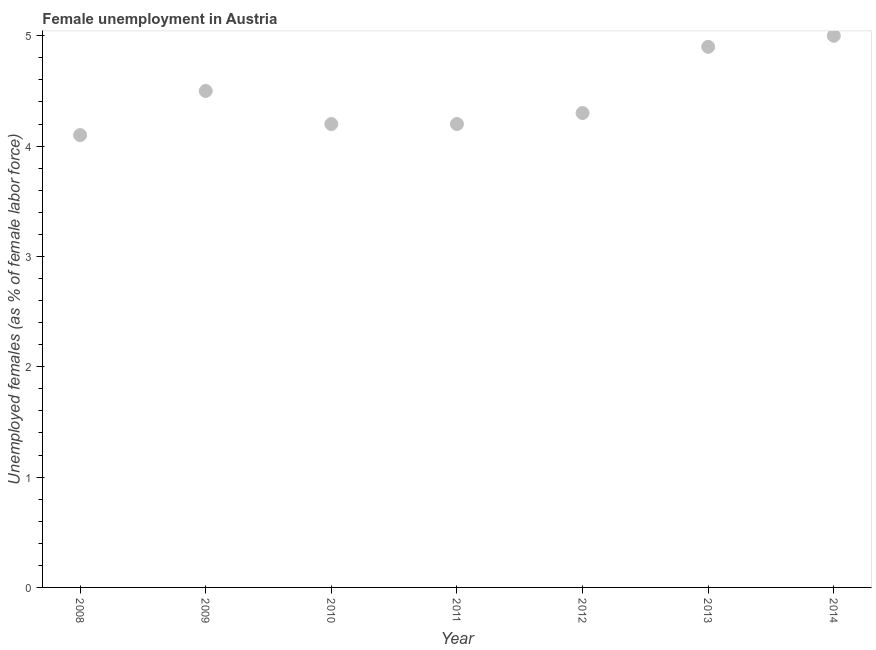What is the unemployed females population in 2011?
Your answer should be very brief. 4.2. Across all years, what is the minimum unemployed females population?
Offer a terse response. 4.1. In which year was the unemployed females population maximum?
Offer a terse response. 2014. In which year was the unemployed females population minimum?
Provide a succinct answer. 2008. What is the sum of the unemployed females population?
Provide a succinct answer. 31.2. What is the difference between the unemployed females population in 2011 and 2014?
Make the answer very short. -0.8. What is the average unemployed females population per year?
Give a very brief answer. 4.46. What is the median unemployed females population?
Provide a short and direct response. 4.3. What is the ratio of the unemployed females population in 2011 to that in 2014?
Provide a short and direct response. 0.84. Is the unemployed females population in 2010 less than that in 2011?
Make the answer very short. No. Is the difference between the unemployed females population in 2013 and 2014 greater than the difference between any two years?
Provide a succinct answer. No. What is the difference between the highest and the second highest unemployed females population?
Provide a succinct answer. 0.1. Is the sum of the unemployed females population in 2009 and 2012 greater than the maximum unemployed females population across all years?
Offer a very short reply. Yes. What is the difference between the highest and the lowest unemployed females population?
Give a very brief answer. 0.9. Does the unemployed females population monotonically increase over the years?
Provide a short and direct response. No. How many years are there in the graph?
Ensure brevity in your answer.  7. Are the values on the major ticks of Y-axis written in scientific E-notation?
Give a very brief answer. No. Does the graph contain any zero values?
Your answer should be compact. No. What is the title of the graph?
Provide a succinct answer. Female unemployment in Austria. What is the label or title of the X-axis?
Provide a succinct answer. Year. What is the label or title of the Y-axis?
Provide a succinct answer. Unemployed females (as % of female labor force). What is the Unemployed females (as % of female labor force) in 2008?
Your response must be concise. 4.1. What is the Unemployed females (as % of female labor force) in 2010?
Keep it short and to the point. 4.2. What is the Unemployed females (as % of female labor force) in 2011?
Your answer should be very brief. 4.2. What is the Unemployed females (as % of female labor force) in 2012?
Provide a succinct answer. 4.3. What is the Unemployed females (as % of female labor force) in 2013?
Provide a short and direct response. 4.9. What is the difference between the Unemployed females (as % of female labor force) in 2008 and 2009?
Provide a short and direct response. -0.4. What is the difference between the Unemployed females (as % of female labor force) in 2008 and 2012?
Your answer should be very brief. -0.2. What is the difference between the Unemployed females (as % of female labor force) in 2008 and 2013?
Ensure brevity in your answer.  -0.8. What is the difference between the Unemployed females (as % of female labor force) in 2008 and 2014?
Offer a terse response. -0.9. What is the difference between the Unemployed females (as % of female labor force) in 2009 and 2011?
Make the answer very short. 0.3. What is the difference between the Unemployed females (as % of female labor force) in 2009 and 2012?
Offer a very short reply. 0.2. What is the difference between the Unemployed females (as % of female labor force) in 2009 and 2013?
Your response must be concise. -0.4. What is the difference between the Unemployed females (as % of female labor force) in 2010 and 2012?
Make the answer very short. -0.1. What is the difference between the Unemployed females (as % of female labor force) in 2011 and 2013?
Give a very brief answer. -0.7. What is the difference between the Unemployed females (as % of female labor force) in 2011 and 2014?
Your response must be concise. -0.8. What is the difference between the Unemployed females (as % of female labor force) in 2012 and 2013?
Make the answer very short. -0.6. What is the ratio of the Unemployed females (as % of female labor force) in 2008 to that in 2009?
Ensure brevity in your answer.  0.91. What is the ratio of the Unemployed females (as % of female labor force) in 2008 to that in 2012?
Your answer should be very brief. 0.95. What is the ratio of the Unemployed females (as % of female labor force) in 2008 to that in 2013?
Your answer should be compact. 0.84. What is the ratio of the Unemployed females (as % of female labor force) in 2008 to that in 2014?
Provide a succinct answer. 0.82. What is the ratio of the Unemployed females (as % of female labor force) in 2009 to that in 2010?
Ensure brevity in your answer.  1.07. What is the ratio of the Unemployed females (as % of female labor force) in 2009 to that in 2011?
Give a very brief answer. 1.07. What is the ratio of the Unemployed females (as % of female labor force) in 2009 to that in 2012?
Offer a very short reply. 1.05. What is the ratio of the Unemployed females (as % of female labor force) in 2009 to that in 2013?
Offer a very short reply. 0.92. What is the ratio of the Unemployed females (as % of female labor force) in 2010 to that in 2012?
Offer a very short reply. 0.98. What is the ratio of the Unemployed females (as % of female labor force) in 2010 to that in 2013?
Ensure brevity in your answer.  0.86. What is the ratio of the Unemployed females (as % of female labor force) in 2010 to that in 2014?
Your answer should be very brief. 0.84. What is the ratio of the Unemployed females (as % of female labor force) in 2011 to that in 2013?
Offer a very short reply. 0.86. What is the ratio of the Unemployed females (as % of female labor force) in 2011 to that in 2014?
Provide a short and direct response. 0.84. What is the ratio of the Unemployed females (as % of female labor force) in 2012 to that in 2013?
Provide a short and direct response. 0.88. What is the ratio of the Unemployed females (as % of female labor force) in 2012 to that in 2014?
Your answer should be compact. 0.86. What is the ratio of the Unemployed females (as % of female labor force) in 2013 to that in 2014?
Provide a short and direct response. 0.98. 